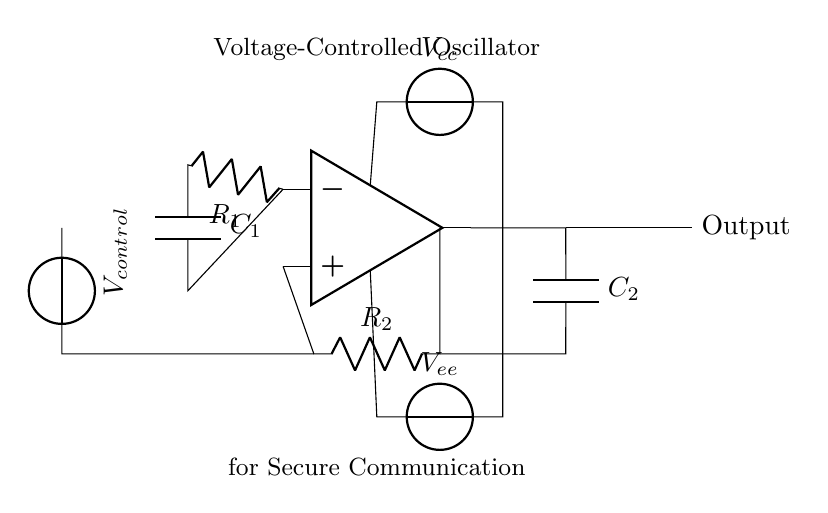What is the type of the main active component used in this circuit? The main active component in this circuit is an operational amplifier, as indicated by the symbol in the circuit. Operational amplifiers are commonly used for signal processing in various electronic circuits, including oscillators.
Answer: operational amplifier What function does R1 serve in this oscillator circuit? R1 acts as a feedback resistor, which influences the gain and frequency characteristics of the oscillator. In a voltage-controlled oscillator, its value, in conjunction with other components, helps determine the output frequency.
Answer: feedback resistor What component is responsible for controlling the frequency of the oscillator? The control voltage V_control applies varying voltage to the circuit, allowing for adjustments of the output frequency, making it a vital component for frequency modulation within this oscillator design.
Answer: V_control How many capacitors are present in this voltage-controlled oscillator circuit? There are two capacitors in the circuit, C1 and C2, which are essential in defining the frequency response and stabilization of the oscillator's operation through their charging and discharging behavior.
Answer: two What is the power supply voltage denoted in this circuit diagram? The power supply voltages are labeled as V_cc for the positive supply and V_ee for the negative supply, though the actual numerical values are not specified in the circuit diagram itself.
Answer: V_cc and V_ee What is the output characteristic represented in the circuit? The output of the circuit is clearly labeled as Output, indicating that it will provide the modulated frequency signal based on the control input, which is essential for secure communications.
Answer: Output Explain the role of C2 in the oscillator circuit. C2 is used to define the output frequency and helps in the feedback loop of the operational amplifier. Capacitors in oscillator circuits often stabilize the output and affect how quickly the circuit responds to changes in control voltage.
Answer: frequency stabilization 